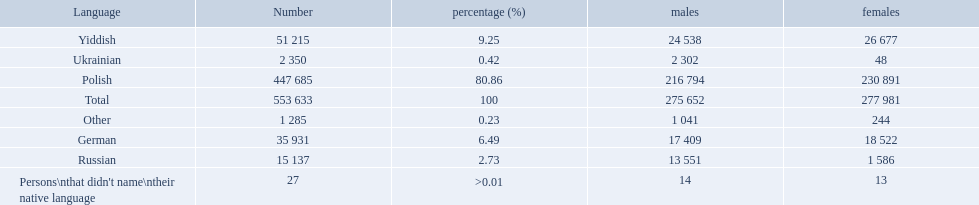Which language options are listed? Polish, Yiddish, German, Russian, Ukrainian, Other, Persons\nthat didn't name\ntheir native language. Of these, which did .42% of the people select? Ukrainian. What was the highest percentage of one language spoken by the plock governorate? 80.86. What language was spoken by 80.86 percent of the people? Polish. 